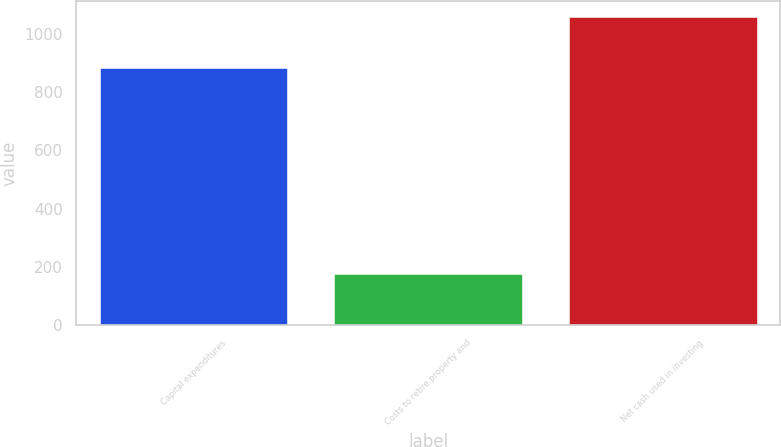Convert chart to OTSL. <chart><loc_0><loc_0><loc_500><loc_500><bar_chart><fcel>Capital expenditures<fcel>Costs to retire property and<fcel>Net cash used in investing<nl><fcel>882<fcel>176<fcel>1058<nl></chart> 